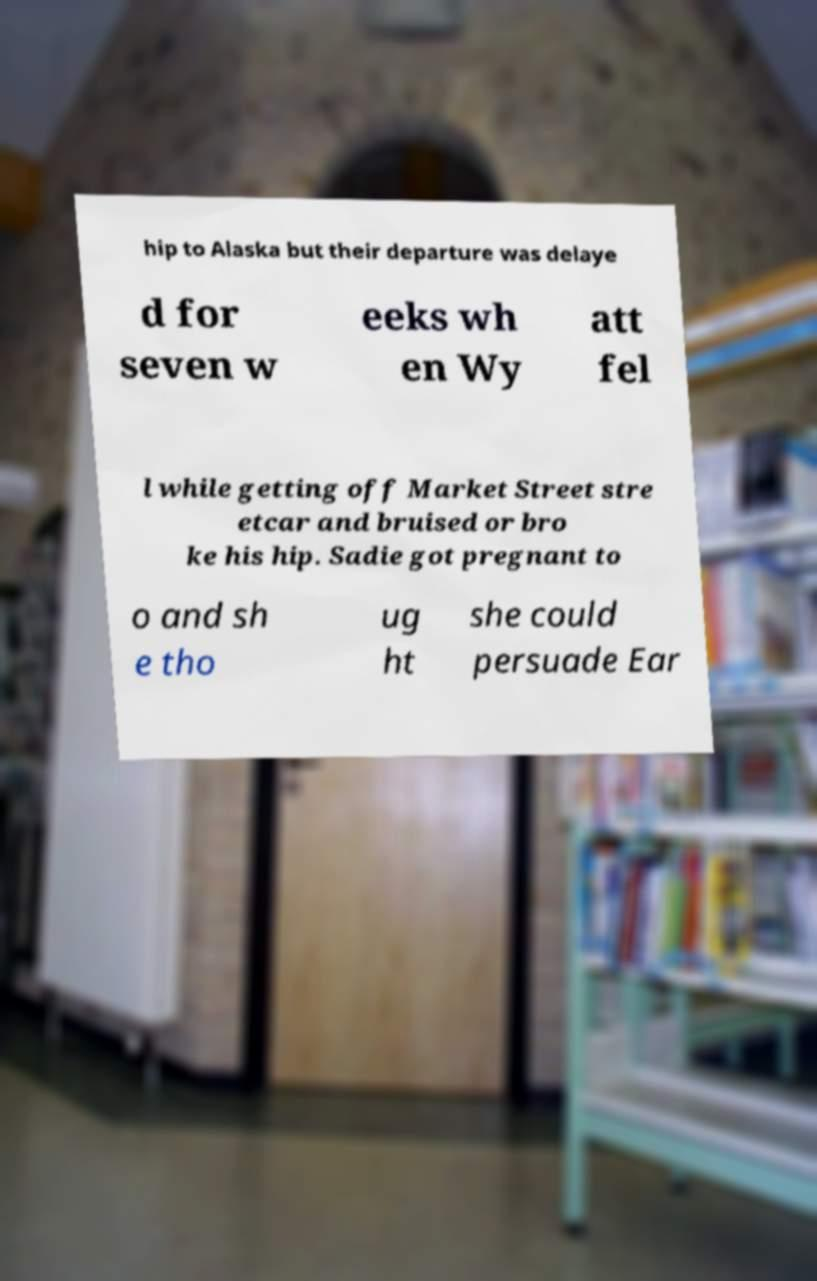Could you extract and type out the text from this image? hip to Alaska but their departure was delaye d for seven w eeks wh en Wy att fel l while getting off Market Street stre etcar and bruised or bro ke his hip. Sadie got pregnant to o and sh e tho ug ht she could persuade Ear 